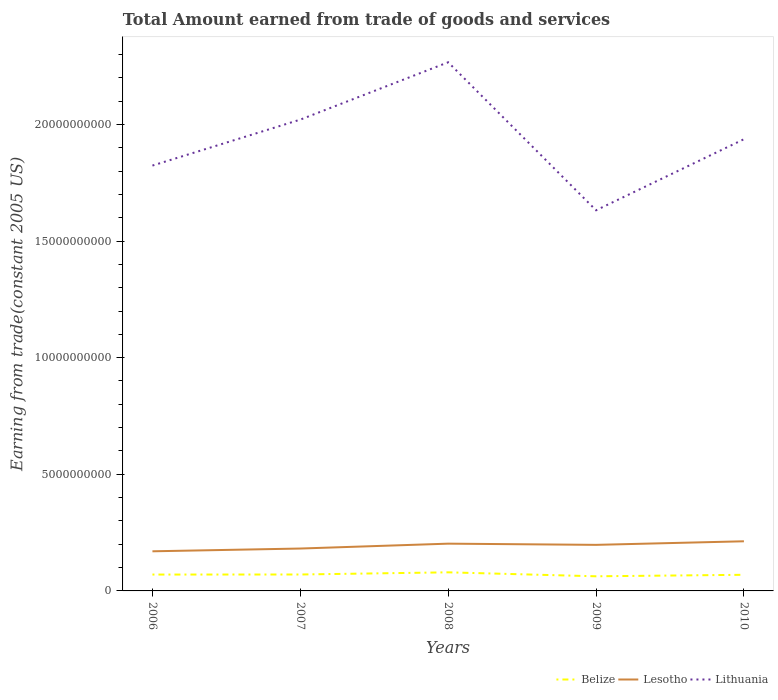Is the number of lines equal to the number of legend labels?
Ensure brevity in your answer.  Yes. Across all years, what is the maximum total amount earned by trading goods and services in Lithuania?
Keep it short and to the point. 1.63e+1. What is the total total amount earned by trading goods and services in Lesotho in the graph?
Give a very brief answer. 5.20e+07. What is the difference between the highest and the second highest total amount earned by trading goods and services in Lesotho?
Your answer should be compact. 4.29e+08. How many lines are there?
Provide a short and direct response. 3. What is the difference between two consecutive major ticks on the Y-axis?
Offer a terse response. 5.00e+09. How many legend labels are there?
Offer a terse response. 3. How are the legend labels stacked?
Provide a short and direct response. Horizontal. What is the title of the graph?
Ensure brevity in your answer.  Total Amount earned from trade of goods and services. Does "Singapore" appear as one of the legend labels in the graph?
Your answer should be compact. No. What is the label or title of the Y-axis?
Ensure brevity in your answer.  Earning from trade(constant 2005 US). What is the Earning from trade(constant 2005 US) in Belize in 2006?
Keep it short and to the point. 7.02e+08. What is the Earning from trade(constant 2005 US) of Lesotho in 2006?
Make the answer very short. 1.70e+09. What is the Earning from trade(constant 2005 US) of Lithuania in 2006?
Ensure brevity in your answer.  1.82e+1. What is the Earning from trade(constant 2005 US) in Belize in 2007?
Offer a very short reply. 7.04e+08. What is the Earning from trade(constant 2005 US) of Lesotho in 2007?
Provide a short and direct response. 1.82e+09. What is the Earning from trade(constant 2005 US) in Lithuania in 2007?
Your response must be concise. 2.02e+1. What is the Earning from trade(constant 2005 US) of Belize in 2008?
Give a very brief answer. 7.97e+08. What is the Earning from trade(constant 2005 US) of Lesotho in 2008?
Keep it short and to the point. 2.03e+09. What is the Earning from trade(constant 2005 US) in Lithuania in 2008?
Give a very brief answer. 2.27e+1. What is the Earning from trade(constant 2005 US) in Belize in 2009?
Your response must be concise. 6.27e+08. What is the Earning from trade(constant 2005 US) in Lesotho in 2009?
Your answer should be very brief. 1.97e+09. What is the Earning from trade(constant 2005 US) of Lithuania in 2009?
Offer a terse response. 1.63e+1. What is the Earning from trade(constant 2005 US) in Belize in 2010?
Provide a succinct answer. 6.92e+08. What is the Earning from trade(constant 2005 US) in Lesotho in 2010?
Ensure brevity in your answer.  2.13e+09. What is the Earning from trade(constant 2005 US) of Lithuania in 2010?
Give a very brief answer. 1.94e+1. Across all years, what is the maximum Earning from trade(constant 2005 US) in Belize?
Keep it short and to the point. 7.97e+08. Across all years, what is the maximum Earning from trade(constant 2005 US) of Lesotho?
Offer a very short reply. 2.13e+09. Across all years, what is the maximum Earning from trade(constant 2005 US) in Lithuania?
Your answer should be compact. 2.27e+1. Across all years, what is the minimum Earning from trade(constant 2005 US) in Belize?
Offer a very short reply. 6.27e+08. Across all years, what is the minimum Earning from trade(constant 2005 US) of Lesotho?
Ensure brevity in your answer.  1.70e+09. Across all years, what is the minimum Earning from trade(constant 2005 US) of Lithuania?
Make the answer very short. 1.63e+1. What is the total Earning from trade(constant 2005 US) in Belize in the graph?
Give a very brief answer. 3.52e+09. What is the total Earning from trade(constant 2005 US) of Lesotho in the graph?
Your answer should be compact. 9.65e+09. What is the total Earning from trade(constant 2005 US) of Lithuania in the graph?
Give a very brief answer. 9.68e+1. What is the difference between the Earning from trade(constant 2005 US) in Belize in 2006 and that in 2007?
Provide a short and direct response. -2.50e+06. What is the difference between the Earning from trade(constant 2005 US) of Lesotho in 2006 and that in 2007?
Offer a terse response. -1.18e+08. What is the difference between the Earning from trade(constant 2005 US) of Lithuania in 2006 and that in 2007?
Give a very brief answer. -1.97e+09. What is the difference between the Earning from trade(constant 2005 US) in Belize in 2006 and that in 2008?
Offer a terse response. -9.54e+07. What is the difference between the Earning from trade(constant 2005 US) of Lesotho in 2006 and that in 2008?
Keep it short and to the point. -3.28e+08. What is the difference between the Earning from trade(constant 2005 US) of Lithuania in 2006 and that in 2008?
Offer a terse response. -4.43e+09. What is the difference between the Earning from trade(constant 2005 US) of Belize in 2006 and that in 2009?
Ensure brevity in your answer.  7.48e+07. What is the difference between the Earning from trade(constant 2005 US) in Lesotho in 2006 and that in 2009?
Your answer should be very brief. -2.76e+08. What is the difference between the Earning from trade(constant 2005 US) in Lithuania in 2006 and that in 2009?
Your response must be concise. 1.92e+09. What is the difference between the Earning from trade(constant 2005 US) in Belize in 2006 and that in 2010?
Give a very brief answer. 1.01e+07. What is the difference between the Earning from trade(constant 2005 US) of Lesotho in 2006 and that in 2010?
Ensure brevity in your answer.  -4.29e+08. What is the difference between the Earning from trade(constant 2005 US) of Lithuania in 2006 and that in 2010?
Your answer should be compact. -1.13e+09. What is the difference between the Earning from trade(constant 2005 US) of Belize in 2007 and that in 2008?
Make the answer very short. -9.29e+07. What is the difference between the Earning from trade(constant 2005 US) of Lesotho in 2007 and that in 2008?
Offer a terse response. -2.09e+08. What is the difference between the Earning from trade(constant 2005 US) of Lithuania in 2007 and that in 2008?
Provide a short and direct response. -2.46e+09. What is the difference between the Earning from trade(constant 2005 US) of Belize in 2007 and that in 2009?
Your answer should be very brief. 7.73e+07. What is the difference between the Earning from trade(constant 2005 US) of Lesotho in 2007 and that in 2009?
Offer a very short reply. -1.57e+08. What is the difference between the Earning from trade(constant 2005 US) of Lithuania in 2007 and that in 2009?
Ensure brevity in your answer.  3.89e+09. What is the difference between the Earning from trade(constant 2005 US) of Belize in 2007 and that in 2010?
Your answer should be very brief. 1.26e+07. What is the difference between the Earning from trade(constant 2005 US) in Lesotho in 2007 and that in 2010?
Ensure brevity in your answer.  -3.11e+08. What is the difference between the Earning from trade(constant 2005 US) in Lithuania in 2007 and that in 2010?
Keep it short and to the point. 8.40e+08. What is the difference between the Earning from trade(constant 2005 US) of Belize in 2008 and that in 2009?
Provide a succinct answer. 1.70e+08. What is the difference between the Earning from trade(constant 2005 US) in Lesotho in 2008 and that in 2009?
Make the answer very short. 5.20e+07. What is the difference between the Earning from trade(constant 2005 US) in Lithuania in 2008 and that in 2009?
Ensure brevity in your answer.  6.35e+09. What is the difference between the Earning from trade(constant 2005 US) of Belize in 2008 and that in 2010?
Keep it short and to the point. 1.05e+08. What is the difference between the Earning from trade(constant 2005 US) in Lesotho in 2008 and that in 2010?
Provide a short and direct response. -1.02e+08. What is the difference between the Earning from trade(constant 2005 US) of Lithuania in 2008 and that in 2010?
Your answer should be compact. 3.30e+09. What is the difference between the Earning from trade(constant 2005 US) of Belize in 2009 and that in 2010?
Give a very brief answer. -6.47e+07. What is the difference between the Earning from trade(constant 2005 US) of Lesotho in 2009 and that in 2010?
Offer a terse response. -1.54e+08. What is the difference between the Earning from trade(constant 2005 US) in Lithuania in 2009 and that in 2010?
Offer a terse response. -3.05e+09. What is the difference between the Earning from trade(constant 2005 US) in Belize in 2006 and the Earning from trade(constant 2005 US) in Lesotho in 2007?
Make the answer very short. -1.12e+09. What is the difference between the Earning from trade(constant 2005 US) of Belize in 2006 and the Earning from trade(constant 2005 US) of Lithuania in 2007?
Your answer should be very brief. -1.95e+1. What is the difference between the Earning from trade(constant 2005 US) of Lesotho in 2006 and the Earning from trade(constant 2005 US) of Lithuania in 2007?
Your response must be concise. -1.85e+1. What is the difference between the Earning from trade(constant 2005 US) in Belize in 2006 and the Earning from trade(constant 2005 US) in Lesotho in 2008?
Your response must be concise. -1.32e+09. What is the difference between the Earning from trade(constant 2005 US) of Belize in 2006 and the Earning from trade(constant 2005 US) of Lithuania in 2008?
Make the answer very short. -2.20e+1. What is the difference between the Earning from trade(constant 2005 US) in Lesotho in 2006 and the Earning from trade(constant 2005 US) in Lithuania in 2008?
Give a very brief answer. -2.10e+1. What is the difference between the Earning from trade(constant 2005 US) of Belize in 2006 and the Earning from trade(constant 2005 US) of Lesotho in 2009?
Your answer should be very brief. -1.27e+09. What is the difference between the Earning from trade(constant 2005 US) of Belize in 2006 and the Earning from trade(constant 2005 US) of Lithuania in 2009?
Your answer should be very brief. -1.56e+1. What is the difference between the Earning from trade(constant 2005 US) in Lesotho in 2006 and the Earning from trade(constant 2005 US) in Lithuania in 2009?
Provide a short and direct response. -1.46e+1. What is the difference between the Earning from trade(constant 2005 US) of Belize in 2006 and the Earning from trade(constant 2005 US) of Lesotho in 2010?
Provide a short and direct response. -1.43e+09. What is the difference between the Earning from trade(constant 2005 US) of Belize in 2006 and the Earning from trade(constant 2005 US) of Lithuania in 2010?
Give a very brief answer. -1.87e+1. What is the difference between the Earning from trade(constant 2005 US) in Lesotho in 2006 and the Earning from trade(constant 2005 US) in Lithuania in 2010?
Your response must be concise. -1.77e+1. What is the difference between the Earning from trade(constant 2005 US) in Belize in 2007 and the Earning from trade(constant 2005 US) in Lesotho in 2008?
Provide a succinct answer. -1.32e+09. What is the difference between the Earning from trade(constant 2005 US) of Belize in 2007 and the Earning from trade(constant 2005 US) of Lithuania in 2008?
Make the answer very short. -2.20e+1. What is the difference between the Earning from trade(constant 2005 US) in Lesotho in 2007 and the Earning from trade(constant 2005 US) in Lithuania in 2008?
Your answer should be compact. -2.08e+1. What is the difference between the Earning from trade(constant 2005 US) in Belize in 2007 and the Earning from trade(constant 2005 US) in Lesotho in 2009?
Offer a very short reply. -1.27e+09. What is the difference between the Earning from trade(constant 2005 US) of Belize in 2007 and the Earning from trade(constant 2005 US) of Lithuania in 2009?
Offer a very short reply. -1.56e+1. What is the difference between the Earning from trade(constant 2005 US) of Lesotho in 2007 and the Earning from trade(constant 2005 US) of Lithuania in 2009?
Offer a terse response. -1.45e+1. What is the difference between the Earning from trade(constant 2005 US) in Belize in 2007 and the Earning from trade(constant 2005 US) in Lesotho in 2010?
Your answer should be very brief. -1.42e+09. What is the difference between the Earning from trade(constant 2005 US) in Belize in 2007 and the Earning from trade(constant 2005 US) in Lithuania in 2010?
Provide a short and direct response. -1.87e+1. What is the difference between the Earning from trade(constant 2005 US) in Lesotho in 2007 and the Earning from trade(constant 2005 US) in Lithuania in 2010?
Offer a terse response. -1.75e+1. What is the difference between the Earning from trade(constant 2005 US) in Belize in 2008 and the Earning from trade(constant 2005 US) in Lesotho in 2009?
Your response must be concise. -1.18e+09. What is the difference between the Earning from trade(constant 2005 US) of Belize in 2008 and the Earning from trade(constant 2005 US) of Lithuania in 2009?
Ensure brevity in your answer.  -1.55e+1. What is the difference between the Earning from trade(constant 2005 US) in Lesotho in 2008 and the Earning from trade(constant 2005 US) in Lithuania in 2009?
Offer a terse response. -1.43e+1. What is the difference between the Earning from trade(constant 2005 US) of Belize in 2008 and the Earning from trade(constant 2005 US) of Lesotho in 2010?
Make the answer very short. -1.33e+09. What is the difference between the Earning from trade(constant 2005 US) in Belize in 2008 and the Earning from trade(constant 2005 US) in Lithuania in 2010?
Your answer should be compact. -1.86e+1. What is the difference between the Earning from trade(constant 2005 US) of Lesotho in 2008 and the Earning from trade(constant 2005 US) of Lithuania in 2010?
Your answer should be compact. -1.73e+1. What is the difference between the Earning from trade(constant 2005 US) of Belize in 2009 and the Earning from trade(constant 2005 US) of Lesotho in 2010?
Offer a terse response. -1.50e+09. What is the difference between the Earning from trade(constant 2005 US) in Belize in 2009 and the Earning from trade(constant 2005 US) in Lithuania in 2010?
Offer a very short reply. -1.87e+1. What is the difference between the Earning from trade(constant 2005 US) in Lesotho in 2009 and the Earning from trade(constant 2005 US) in Lithuania in 2010?
Your response must be concise. -1.74e+1. What is the average Earning from trade(constant 2005 US) in Belize per year?
Give a very brief answer. 7.04e+08. What is the average Earning from trade(constant 2005 US) of Lesotho per year?
Your answer should be compact. 1.93e+09. What is the average Earning from trade(constant 2005 US) in Lithuania per year?
Your response must be concise. 1.94e+1. In the year 2006, what is the difference between the Earning from trade(constant 2005 US) in Belize and Earning from trade(constant 2005 US) in Lesotho?
Ensure brevity in your answer.  -9.97e+08. In the year 2006, what is the difference between the Earning from trade(constant 2005 US) in Belize and Earning from trade(constant 2005 US) in Lithuania?
Make the answer very short. -1.75e+1. In the year 2006, what is the difference between the Earning from trade(constant 2005 US) in Lesotho and Earning from trade(constant 2005 US) in Lithuania?
Provide a short and direct response. -1.65e+1. In the year 2007, what is the difference between the Earning from trade(constant 2005 US) of Belize and Earning from trade(constant 2005 US) of Lesotho?
Your answer should be compact. -1.11e+09. In the year 2007, what is the difference between the Earning from trade(constant 2005 US) in Belize and Earning from trade(constant 2005 US) in Lithuania?
Make the answer very short. -1.95e+1. In the year 2007, what is the difference between the Earning from trade(constant 2005 US) in Lesotho and Earning from trade(constant 2005 US) in Lithuania?
Provide a short and direct response. -1.84e+1. In the year 2008, what is the difference between the Earning from trade(constant 2005 US) in Belize and Earning from trade(constant 2005 US) in Lesotho?
Provide a succinct answer. -1.23e+09. In the year 2008, what is the difference between the Earning from trade(constant 2005 US) in Belize and Earning from trade(constant 2005 US) in Lithuania?
Keep it short and to the point. -2.19e+1. In the year 2008, what is the difference between the Earning from trade(constant 2005 US) of Lesotho and Earning from trade(constant 2005 US) of Lithuania?
Offer a terse response. -2.06e+1. In the year 2009, what is the difference between the Earning from trade(constant 2005 US) in Belize and Earning from trade(constant 2005 US) in Lesotho?
Offer a very short reply. -1.35e+09. In the year 2009, what is the difference between the Earning from trade(constant 2005 US) of Belize and Earning from trade(constant 2005 US) of Lithuania?
Give a very brief answer. -1.57e+1. In the year 2009, what is the difference between the Earning from trade(constant 2005 US) in Lesotho and Earning from trade(constant 2005 US) in Lithuania?
Make the answer very short. -1.43e+1. In the year 2010, what is the difference between the Earning from trade(constant 2005 US) in Belize and Earning from trade(constant 2005 US) in Lesotho?
Your response must be concise. -1.44e+09. In the year 2010, what is the difference between the Earning from trade(constant 2005 US) of Belize and Earning from trade(constant 2005 US) of Lithuania?
Your answer should be very brief. -1.87e+1. In the year 2010, what is the difference between the Earning from trade(constant 2005 US) of Lesotho and Earning from trade(constant 2005 US) of Lithuania?
Provide a succinct answer. -1.72e+1. What is the ratio of the Earning from trade(constant 2005 US) of Belize in 2006 to that in 2007?
Your answer should be very brief. 1. What is the ratio of the Earning from trade(constant 2005 US) of Lesotho in 2006 to that in 2007?
Give a very brief answer. 0.93. What is the ratio of the Earning from trade(constant 2005 US) of Lithuania in 2006 to that in 2007?
Your answer should be very brief. 0.9. What is the ratio of the Earning from trade(constant 2005 US) of Belize in 2006 to that in 2008?
Offer a very short reply. 0.88. What is the ratio of the Earning from trade(constant 2005 US) in Lesotho in 2006 to that in 2008?
Offer a very short reply. 0.84. What is the ratio of the Earning from trade(constant 2005 US) of Lithuania in 2006 to that in 2008?
Provide a short and direct response. 0.8. What is the ratio of the Earning from trade(constant 2005 US) in Belize in 2006 to that in 2009?
Provide a succinct answer. 1.12. What is the ratio of the Earning from trade(constant 2005 US) of Lesotho in 2006 to that in 2009?
Keep it short and to the point. 0.86. What is the ratio of the Earning from trade(constant 2005 US) in Lithuania in 2006 to that in 2009?
Your answer should be compact. 1.12. What is the ratio of the Earning from trade(constant 2005 US) in Belize in 2006 to that in 2010?
Make the answer very short. 1.01. What is the ratio of the Earning from trade(constant 2005 US) in Lesotho in 2006 to that in 2010?
Make the answer very short. 0.8. What is the ratio of the Earning from trade(constant 2005 US) in Lithuania in 2006 to that in 2010?
Keep it short and to the point. 0.94. What is the ratio of the Earning from trade(constant 2005 US) in Belize in 2007 to that in 2008?
Your answer should be compact. 0.88. What is the ratio of the Earning from trade(constant 2005 US) of Lesotho in 2007 to that in 2008?
Your answer should be compact. 0.9. What is the ratio of the Earning from trade(constant 2005 US) of Lithuania in 2007 to that in 2008?
Provide a short and direct response. 0.89. What is the ratio of the Earning from trade(constant 2005 US) of Belize in 2007 to that in 2009?
Offer a terse response. 1.12. What is the ratio of the Earning from trade(constant 2005 US) of Lesotho in 2007 to that in 2009?
Ensure brevity in your answer.  0.92. What is the ratio of the Earning from trade(constant 2005 US) in Lithuania in 2007 to that in 2009?
Provide a short and direct response. 1.24. What is the ratio of the Earning from trade(constant 2005 US) of Belize in 2007 to that in 2010?
Your answer should be very brief. 1.02. What is the ratio of the Earning from trade(constant 2005 US) of Lesotho in 2007 to that in 2010?
Provide a short and direct response. 0.85. What is the ratio of the Earning from trade(constant 2005 US) of Lithuania in 2007 to that in 2010?
Keep it short and to the point. 1.04. What is the ratio of the Earning from trade(constant 2005 US) in Belize in 2008 to that in 2009?
Provide a succinct answer. 1.27. What is the ratio of the Earning from trade(constant 2005 US) of Lesotho in 2008 to that in 2009?
Keep it short and to the point. 1.03. What is the ratio of the Earning from trade(constant 2005 US) of Lithuania in 2008 to that in 2009?
Provide a short and direct response. 1.39. What is the ratio of the Earning from trade(constant 2005 US) in Belize in 2008 to that in 2010?
Provide a short and direct response. 1.15. What is the ratio of the Earning from trade(constant 2005 US) of Lesotho in 2008 to that in 2010?
Keep it short and to the point. 0.95. What is the ratio of the Earning from trade(constant 2005 US) of Lithuania in 2008 to that in 2010?
Make the answer very short. 1.17. What is the ratio of the Earning from trade(constant 2005 US) in Belize in 2009 to that in 2010?
Offer a very short reply. 0.91. What is the ratio of the Earning from trade(constant 2005 US) of Lesotho in 2009 to that in 2010?
Offer a terse response. 0.93. What is the ratio of the Earning from trade(constant 2005 US) in Lithuania in 2009 to that in 2010?
Your response must be concise. 0.84. What is the difference between the highest and the second highest Earning from trade(constant 2005 US) of Belize?
Provide a succinct answer. 9.29e+07. What is the difference between the highest and the second highest Earning from trade(constant 2005 US) in Lesotho?
Your answer should be very brief. 1.02e+08. What is the difference between the highest and the second highest Earning from trade(constant 2005 US) in Lithuania?
Your answer should be compact. 2.46e+09. What is the difference between the highest and the lowest Earning from trade(constant 2005 US) in Belize?
Offer a very short reply. 1.70e+08. What is the difference between the highest and the lowest Earning from trade(constant 2005 US) in Lesotho?
Keep it short and to the point. 4.29e+08. What is the difference between the highest and the lowest Earning from trade(constant 2005 US) in Lithuania?
Offer a very short reply. 6.35e+09. 